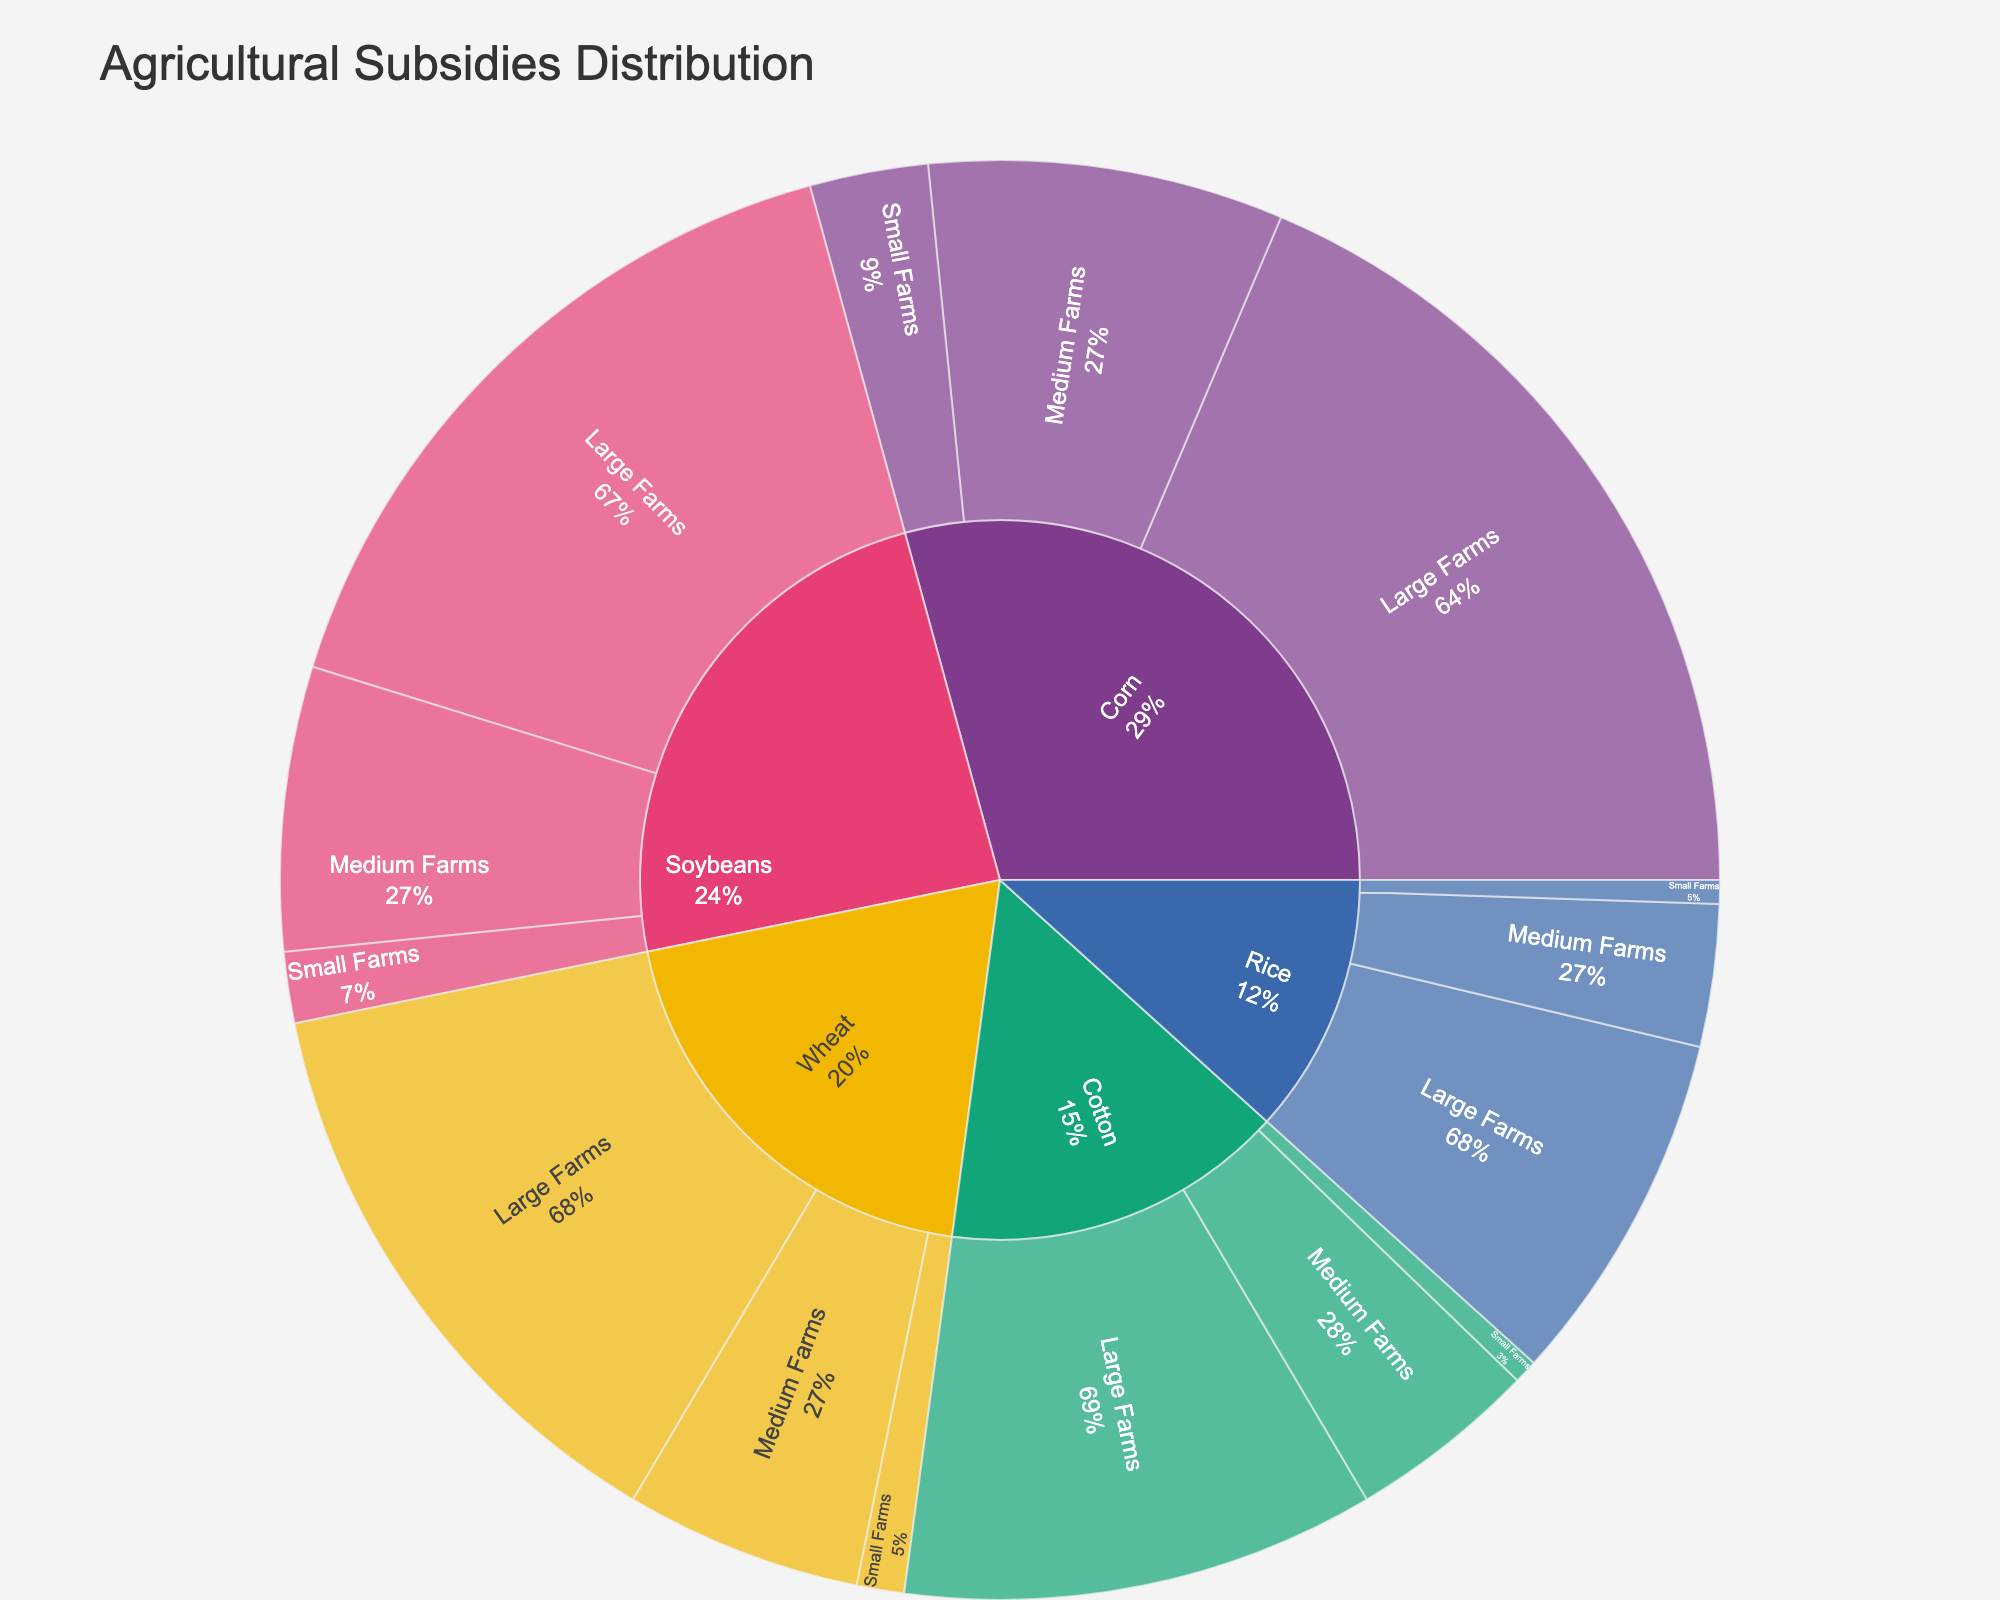Which crop category receives the highest total subsidies? To find the answer, look at the largest section in the outer ring of the sunburst plot. The "Corn" category has the largest share among all crop categories.
Answer: Corn How much more in subsidies do large farms receive compared to small farms for soybeans? Check the values for "Large Farms" and "Small Farms" under the "Soybeans" category. Large farms receive 30 units and small farms receive 3 units. Subtract the smaller value from the larger one: 30 - 3 = 27.
Answer: 27 Which category and subcategory have the smallest value together? Look for the smallest section in the figure. The "Cotton" under "Small Farms" has the smallest segment with a value of 1 unit.
Answer: Cotton, Small Farms What is the total value of subsidies received by medium farms? Sum the values of the "Medium Farms" subcategory across all crop categories. These are 15 (Corn) + 12 (Soybeans) + 10 (Wheat) + 8 (Cotton) + 6 (Rice) = 51 units.
Answer: 51 How do the subsidies for large farms in wheat compare to those for large farms in cotton? Compare the "Large Farms" segments under "Wheat" (25) and "Cotton" (20). Wheat receives more subsidies.
Answer: Wheat receives more Which farm size gets the most subsidies for rice, and how much is it? Check the "Rice" category and compare the segments of "Large Farms" (15), "Medium Farms" (6), and "Small Farms" (1). "Large Farms" receives the most subsidies.
Answer: Large Farms, 15 What percentage of the total subsidies for corn goes to medium farms? First, find the total subsidies for corn: 35 (Large Farms) + 15 (Medium Farms) + 5 (Small Farms) = 55 units. Then, calculate the percentage: (15 / 55) * 100 = 27.3%.
Answer: 27.3% If we combine the subsidies for small farms across all crops, what is the total value? Sum the values of the "Small Farms" subcategories: 5 (Corn) + 3 (Soybeans) + 2 (Wheat) + 1 (Cotton) + 1 (Rice) = 12 units.
Answer: 12 Which crop has the largest discrepancy in subsidies between large and small farms? Calculate the differences for each crop category and find the largest one: Corn (35-5 = 30), Soybeans (30-3 = 27), Wheat (25-2= 23), Cotton (20-1 = 19), Rice (15-1 = 14). The largest discrepancy is for Corn.
Answer: Corn Are medium farms for corn receiving more subsidies than small farms for wheat? Look at the figures for "Medium Farms" in the "Corn" category (15) and "Small Farms" in the "Wheat" category (2). Medium farms for corn receive more.
Answer: Yes 